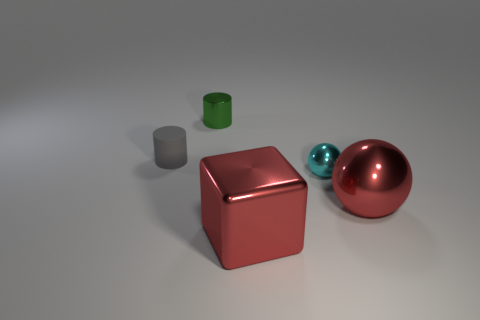Add 4 tiny rubber balls. How many objects exist? 9 Subtract 2 spheres. How many spheres are left? 0 Subtract all cylinders. How many objects are left? 3 Subtract all gray cylinders. How many cylinders are left? 1 Add 4 small gray matte cylinders. How many small gray matte cylinders exist? 5 Subtract 0 yellow blocks. How many objects are left? 5 Subtract all brown cubes. Subtract all brown cylinders. How many cubes are left? 1 Subtract all gray balls. How many purple blocks are left? 0 Subtract all tiny red matte balls. Subtract all large red metal spheres. How many objects are left? 4 Add 3 small metallic objects. How many small metallic objects are left? 5 